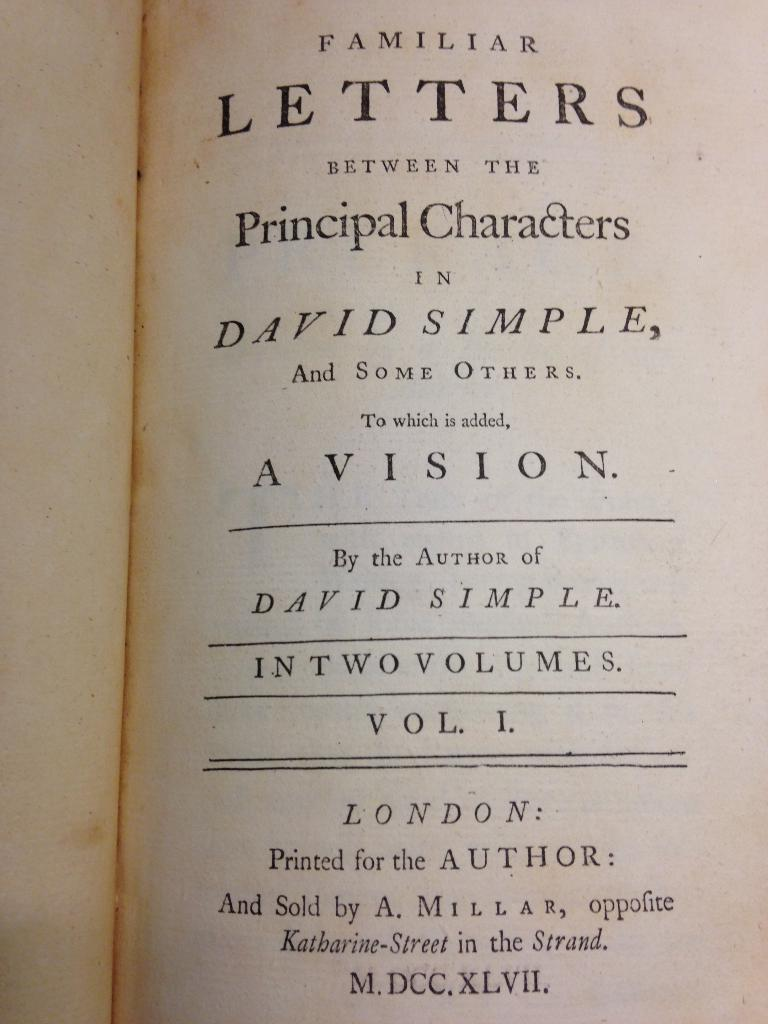<image>
Provide a brief description of the given image. A book is opened to a title page and lists that it was sold by A. Millar. 